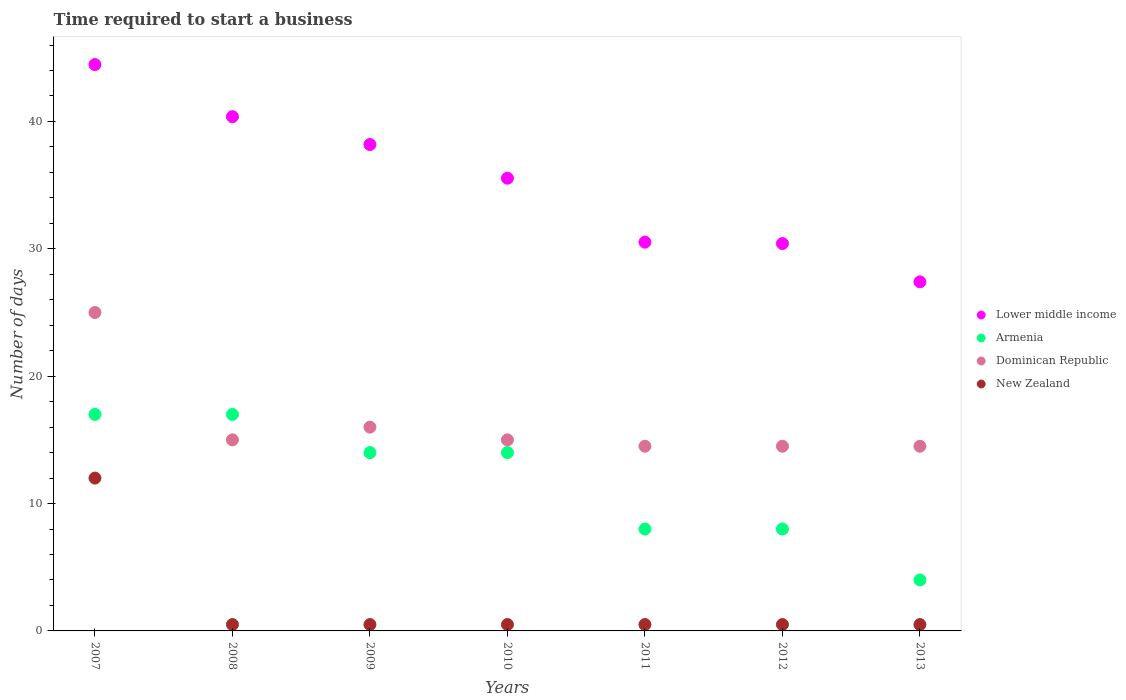What is the number of days required to start a business in New Zealand in 2011?
Provide a succinct answer. 0.5. Across all years, what is the maximum number of days required to start a business in Lower middle income?
Provide a short and direct response. 44.47. In which year was the number of days required to start a business in Lower middle income maximum?
Offer a terse response. 2007. What is the total number of days required to start a business in Armenia in the graph?
Offer a terse response. 82. What is the difference between the number of days required to start a business in Lower middle income in 2010 and that in 2013?
Offer a terse response. 8.14. What is the difference between the number of days required to start a business in Dominican Republic in 2009 and the number of days required to start a business in Lower middle income in 2007?
Your response must be concise. -28.47. What is the average number of days required to start a business in Armenia per year?
Your answer should be very brief. 11.71. In the year 2007, what is the difference between the number of days required to start a business in Armenia and number of days required to start a business in New Zealand?
Your response must be concise. 5. What is the ratio of the number of days required to start a business in Lower middle income in 2007 to that in 2013?
Your answer should be compact. 1.62. Is the number of days required to start a business in New Zealand in 2007 less than that in 2013?
Offer a terse response. No. Is the difference between the number of days required to start a business in Armenia in 2007 and 2012 greater than the difference between the number of days required to start a business in New Zealand in 2007 and 2012?
Make the answer very short. No. What is the difference between the highest and the second highest number of days required to start a business in Dominican Republic?
Ensure brevity in your answer.  9. What is the difference between the highest and the lowest number of days required to start a business in New Zealand?
Your response must be concise. 11.5. Is the sum of the number of days required to start a business in New Zealand in 2008 and 2009 greater than the maximum number of days required to start a business in Armenia across all years?
Keep it short and to the point. No. Is it the case that in every year, the sum of the number of days required to start a business in Armenia and number of days required to start a business in Lower middle income  is greater than the number of days required to start a business in Dominican Republic?
Offer a terse response. Yes. Does the number of days required to start a business in New Zealand monotonically increase over the years?
Ensure brevity in your answer.  No. Is the number of days required to start a business in Armenia strictly less than the number of days required to start a business in Lower middle income over the years?
Ensure brevity in your answer.  Yes. How many dotlines are there?
Your answer should be very brief. 4. How many years are there in the graph?
Provide a succinct answer. 7. What is the difference between two consecutive major ticks on the Y-axis?
Offer a very short reply. 10. Are the values on the major ticks of Y-axis written in scientific E-notation?
Your response must be concise. No. How many legend labels are there?
Your answer should be very brief. 4. What is the title of the graph?
Provide a succinct answer. Time required to start a business. Does "United Kingdom" appear as one of the legend labels in the graph?
Provide a short and direct response. No. What is the label or title of the Y-axis?
Your answer should be compact. Number of days. What is the Number of days of Lower middle income in 2007?
Your answer should be very brief. 44.47. What is the Number of days in Dominican Republic in 2007?
Your answer should be very brief. 25. What is the Number of days in Lower middle income in 2008?
Provide a succinct answer. 40.38. What is the Number of days of Armenia in 2008?
Your answer should be very brief. 17. What is the Number of days in Dominican Republic in 2008?
Provide a short and direct response. 15. What is the Number of days of Lower middle income in 2009?
Make the answer very short. 38.19. What is the Number of days in Armenia in 2009?
Offer a terse response. 14. What is the Number of days in Lower middle income in 2010?
Give a very brief answer. 35.54. What is the Number of days in New Zealand in 2010?
Provide a succinct answer. 0.5. What is the Number of days in Lower middle income in 2011?
Ensure brevity in your answer.  30.52. What is the Number of days in Armenia in 2011?
Your answer should be compact. 8. What is the Number of days in New Zealand in 2011?
Make the answer very short. 0.5. What is the Number of days in Lower middle income in 2012?
Your answer should be very brief. 30.41. What is the Number of days of Armenia in 2012?
Your response must be concise. 8. What is the Number of days in Dominican Republic in 2012?
Your answer should be compact. 14.5. What is the Number of days in Lower middle income in 2013?
Offer a terse response. 27.41. What is the Number of days of Armenia in 2013?
Provide a succinct answer. 4. Across all years, what is the maximum Number of days of Lower middle income?
Make the answer very short. 44.47. Across all years, what is the maximum Number of days of Armenia?
Provide a succinct answer. 17. Across all years, what is the maximum Number of days of New Zealand?
Keep it short and to the point. 12. Across all years, what is the minimum Number of days in Lower middle income?
Your response must be concise. 27.41. Across all years, what is the minimum Number of days of Dominican Republic?
Keep it short and to the point. 14.5. Across all years, what is the minimum Number of days in New Zealand?
Your answer should be compact. 0.5. What is the total Number of days of Lower middle income in the graph?
Your answer should be compact. 246.92. What is the total Number of days in Dominican Republic in the graph?
Keep it short and to the point. 114.5. What is the total Number of days of New Zealand in the graph?
Your response must be concise. 15. What is the difference between the Number of days of Lower middle income in 2007 and that in 2008?
Provide a short and direct response. 4.09. What is the difference between the Number of days in Dominican Republic in 2007 and that in 2008?
Your answer should be very brief. 10. What is the difference between the Number of days of New Zealand in 2007 and that in 2008?
Your answer should be compact. 11.5. What is the difference between the Number of days of Lower middle income in 2007 and that in 2009?
Offer a terse response. 6.28. What is the difference between the Number of days of Armenia in 2007 and that in 2009?
Keep it short and to the point. 3. What is the difference between the Number of days in Lower middle income in 2007 and that in 2010?
Give a very brief answer. 8.92. What is the difference between the Number of days of Armenia in 2007 and that in 2010?
Your response must be concise. 3. What is the difference between the Number of days of Dominican Republic in 2007 and that in 2010?
Keep it short and to the point. 10. What is the difference between the Number of days of New Zealand in 2007 and that in 2010?
Your answer should be very brief. 11.5. What is the difference between the Number of days in Lower middle income in 2007 and that in 2011?
Offer a terse response. 13.94. What is the difference between the Number of days of Armenia in 2007 and that in 2011?
Offer a very short reply. 9. What is the difference between the Number of days in New Zealand in 2007 and that in 2011?
Your answer should be compact. 11.5. What is the difference between the Number of days in Lower middle income in 2007 and that in 2012?
Give a very brief answer. 14.05. What is the difference between the Number of days in Dominican Republic in 2007 and that in 2012?
Your answer should be compact. 10.5. What is the difference between the Number of days in New Zealand in 2007 and that in 2012?
Make the answer very short. 11.5. What is the difference between the Number of days in Lower middle income in 2007 and that in 2013?
Offer a very short reply. 17.06. What is the difference between the Number of days of Armenia in 2007 and that in 2013?
Your response must be concise. 13. What is the difference between the Number of days in New Zealand in 2007 and that in 2013?
Ensure brevity in your answer.  11.5. What is the difference between the Number of days of Lower middle income in 2008 and that in 2009?
Your answer should be compact. 2.19. What is the difference between the Number of days of New Zealand in 2008 and that in 2009?
Offer a terse response. 0. What is the difference between the Number of days of Lower middle income in 2008 and that in 2010?
Your answer should be compact. 4.83. What is the difference between the Number of days of Armenia in 2008 and that in 2010?
Your answer should be very brief. 3. What is the difference between the Number of days of Lower middle income in 2008 and that in 2011?
Offer a very short reply. 9.85. What is the difference between the Number of days of New Zealand in 2008 and that in 2011?
Provide a succinct answer. 0. What is the difference between the Number of days of Lower middle income in 2008 and that in 2012?
Your response must be concise. 9.96. What is the difference between the Number of days of Lower middle income in 2008 and that in 2013?
Your answer should be very brief. 12.97. What is the difference between the Number of days in Armenia in 2008 and that in 2013?
Offer a terse response. 13. What is the difference between the Number of days in Dominican Republic in 2008 and that in 2013?
Make the answer very short. 0.5. What is the difference between the Number of days in Lower middle income in 2009 and that in 2010?
Give a very brief answer. 2.64. What is the difference between the Number of days in Dominican Republic in 2009 and that in 2010?
Give a very brief answer. 1. What is the difference between the Number of days in Lower middle income in 2009 and that in 2011?
Provide a short and direct response. 7.67. What is the difference between the Number of days in Lower middle income in 2009 and that in 2012?
Your response must be concise. 7.78. What is the difference between the Number of days in Dominican Republic in 2009 and that in 2012?
Give a very brief answer. 1.5. What is the difference between the Number of days in Lower middle income in 2009 and that in 2013?
Give a very brief answer. 10.78. What is the difference between the Number of days of Armenia in 2009 and that in 2013?
Offer a very short reply. 10. What is the difference between the Number of days of Lower middle income in 2010 and that in 2011?
Give a very brief answer. 5.02. What is the difference between the Number of days in Armenia in 2010 and that in 2011?
Your response must be concise. 6. What is the difference between the Number of days in New Zealand in 2010 and that in 2011?
Offer a terse response. 0. What is the difference between the Number of days of Lower middle income in 2010 and that in 2012?
Keep it short and to the point. 5.13. What is the difference between the Number of days in New Zealand in 2010 and that in 2012?
Your response must be concise. 0. What is the difference between the Number of days in Lower middle income in 2010 and that in 2013?
Your answer should be compact. 8.14. What is the difference between the Number of days of Armenia in 2010 and that in 2013?
Your response must be concise. 10. What is the difference between the Number of days of Dominican Republic in 2010 and that in 2013?
Give a very brief answer. 0.5. What is the difference between the Number of days of New Zealand in 2010 and that in 2013?
Give a very brief answer. 0. What is the difference between the Number of days of Lower middle income in 2011 and that in 2012?
Provide a short and direct response. 0.11. What is the difference between the Number of days in Lower middle income in 2011 and that in 2013?
Your answer should be very brief. 3.11. What is the difference between the Number of days in Dominican Republic in 2011 and that in 2013?
Your answer should be very brief. 0. What is the difference between the Number of days of Lower middle income in 2012 and that in 2013?
Keep it short and to the point. 3.01. What is the difference between the Number of days in Lower middle income in 2007 and the Number of days in Armenia in 2008?
Offer a terse response. 27.47. What is the difference between the Number of days of Lower middle income in 2007 and the Number of days of Dominican Republic in 2008?
Provide a succinct answer. 29.47. What is the difference between the Number of days in Lower middle income in 2007 and the Number of days in New Zealand in 2008?
Offer a terse response. 43.97. What is the difference between the Number of days of Lower middle income in 2007 and the Number of days of Armenia in 2009?
Provide a succinct answer. 30.47. What is the difference between the Number of days in Lower middle income in 2007 and the Number of days in Dominican Republic in 2009?
Offer a very short reply. 28.47. What is the difference between the Number of days of Lower middle income in 2007 and the Number of days of New Zealand in 2009?
Offer a very short reply. 43.97. What is the difference between the Number of days in Armenia in 2007 and the Number of days in New Zealand in 2009?
Ensure brevity in your answer.  16.5. What is the difference between the Number of days of Lower middle income in 2007 and the Number of days of Armenia in 2010?
Your answer should be compact. 30.47. What is the difference between the Number of days in Lower middle income in 2007 and the Number of days in Dominican Republic in 2010?
Your response must be concise. 29.47. What is the difference between the Number of days in Lower middle income in 2007 and the Number of days in New Zealand in 2010?
Keep it short and to the point. 43.97. What is the difference between the Number of days in Armenia in 2007 and the Number of days in Dominican Republic in 2010?
Offer a very short reply. 2. What is the difference between the Number of days of Dominican Republic in 2007 and the Number of days of New Zealand in 2010?
Your answer should be very brief. 24.5. What is the difference between the Number of days of Lower middle income in 2007 and the Number of days of Armenia in 2011?
Provide a short and direct response. 36.47. What is the difference between the Number of days of Lower middle income in 2007 and the Number of days of Dominican Republic in 2011?
Your answer should be very brief. 29.97. What is the difference between the Number of days in Lower middle income in 2007 and the Number of days in New Zealand in 2011?
Ensure brevity in your answer.  43.97. What is the difference between the Number of days of Lower middle income in 2007 and the Number of days of Armenia in 2012?
Keep it short and to the point. 36.47. What is the difference between the Number of days in Lower middle income in 2007 and the Number of days in Dominican Republic in 2012?
Your answer should be very brief. 29.97. What is the difference between the Number of days in Lower middle income in 2007 and the Number of days in New Zealand in 2012?
Give a very brief answer. 43.97. What is the difference between the Number of days of Lower middle income in 2007 and the Number of days of Armenia in 2013?
Your answer should be very brief. 40.47. What is the difference between the Number of days of Lower middle income in 2007 and the Number of days of Dominican Republic in 2013?
Your answer should be very brief. 29.97. What is the difference between the Number of days in Lower middle income in 2007 and the Number of days in New Zealand in 2013?
Provide a short and direct response. 43.97. What is the difference between the Number of days of Armenia in 2007 and the Number of days of Dominican Republic in 2013?
Give a very brief answer. 2.5. What is the difference between the Number of days of Armenia in 2007 and the Number of days of New Zealand in 2013?
Your answer should be very brief. 16.5. What is the difference between the Number of days in Dominican Republic in 2007 and the Number of days in New Zealand in 2013?
Provide a succinct answer. 24.5. What is the difference between the Number of days of Lower middle income in 2008 and the Number of days of Armenia in 2009?
Your answer should be compact. 26.38. What is the difference between the Number of days in Lower middle income in 2008 and the Number of days in Dominican Republic in 2009?
Offer a terse response. 24.38. What is the difference between the Number of days of Lower middle income in 2008 and the Number of days of New Zealand in 2009?
Your answer should be very brief. 39.88. What is the difference between the Number of days of Armenia in 2008 and the Number of days of Dominican Republic in 2009?
Make the answer very short. 1. What is the difference between the Number of days in Dominican Republic in 2008 and the Number of days in New Zealand in 2009?
Your answer should be very brief. 14.5. What is the difference between the Number of days in Lower middle income in 2008 and the Number of days in Armenia in 2010?
Your answer should be compact. 26.38. What is the difference between the Number of days in Lower middle income in 2008 and the Number of days in Dominican Republic in 2010?
Your answer should be compact. 25.38. What is the difference between the Number of days of Lower middle income in 2008 and the Number of days of New Zealand in 2010?
Provide a short and direct response. 39.88. What is the difference between the Number of days of Armenia in 2008 and the Number of days of Dominican Republic in 2010?
Make the answer very short. 2. What is the difference between the Number of days of Dominican Republic in 2008 and the Number of days of New Zealand in 2010?
Keep it short and to the point. 14.5. What is the difference between the Number of days of Lower middle income in 2008 and the Number of days of Armenia in 2011?
Provide a short and direct response. 32.38. What is the difference between the Number of days in Lower middle income in 2008 and the Number of days in Dominican Republic in 2011?
Provide a short and direct response. 25.88. What is the difference between the Number of days in Lower middle income in 2008 and the Number of days in New Zealand in 2011?
Your answer should be very brief. 39.88. What is the difference between the Number of days of Armenia in 2008 and the Number of days of Dominican Republic in 2011?
Offer a very short reply. 2.5. What is the difference between the Number of days of Armenia in 2008 and the Number of days of New Zealand in 2011?
Offer a terse response. 16.5. What is the difference between the Number of days of Lower middle income in 2008 and the Number of days of Armenia in 2012?
Offer a very short reply. 32.38. What is the difference between the Number of days of Lower middle income in 2008 and the Number of days of Dominican Republic in 2012?
Make the answer very short. 25.88. What is the difference between the Number of days in Lower middle income in 2008 and the Number of days in New Zealand in 2012?
Offer a very short reply. 39.88. What is the difference between the Number of days of Armenia in 2008 and the Number of days of New Zealand in 2012?
Offer a terse response. 16.5. What is the difference between the Number of days in Lower middle income in 2008 and the Number of days in Armenia in 2013?
Your answer should be compact. 36.38. What is the difference between the Number of days of Lower middle income in 2008 and the Number of days of Dominican Republic in 2013?
Your answer should be compact. 25.88. What is the difference between the Number of days in Lower middle income in 2008 and the Number of days in New Zealand in 2013?
Provide a short and direct response. 39.88. What is the difference between the Number of days in Lower middle income in 2009 and the Number of days in Armenia in 2010?
Provide a short and direct response. 24.19. What is the difference between the Number of days in Lower middle income in 2009 and the Number of days in Dominican Republic in 2010?
Keep it short and to the point. 23.19. What is the difference between the Number of days in Lower middle income in 2009 and the Number of days in New Zealand in 2010?
Ensure brevity in your answer.  37.69. What is the difference between the Number of days of Armenia in 2009 and the Number of days of Dominican Republic in 2010?
Make the answer very short. -1. What is the difference between the Number of days of Lower middle income in 2009 and the Number of days of Armenia in 2011?
Make the answer very short. 30.19. What is the difference between the Number of days of Lower middle income in 2009 and the Number of days of Dominican Republic in 2011?
Provide a short and direct response. 23.69. What is the difference between the Number of days in Lower middle income in 2009 and the Number of days in New Zealand in 2011?
Offer a very short reply. 37.69. What is the difference between the Number of days in Lower middle income in 2009 and the Number of days in Armenia in 2012?
Ensure brevity in your answer.  30.19. What is the difference between the Number of days of Lower middle income in 2009 and the Number of days of Dominican Republic in 2012?
Offer a very short reply. 23.69. What is the difference between the Number of days in Lower middle income in 2009 and the Number of days in New Zealand in 2012?
Ensure brevity in your answer.  37.69. What is the difference between the Number of days in Armenia in 2009 and the Number of days in New Zealand in 2012?
Provide a short and direct response. 13.5. What is the difference between the Number of days of Lower middle income in 2009 and the Number of days of Armenia in 2013?
Ensure brevity in your answer.  34.19. What is the difference between the Number of days of Lower middle income in 2009 and the Number of days of Dominican Republic in 2013?
Your answer should be very brief. 23.69. What is the difference between the Number of days in Lower middle income in 2009 and the Number of days in New Zealand in 2013?
Your answer should be very brief. 37.69. What is the difference between the Number of days of Armenia in 2009 and the Number of days of New Zealand in 2013?
Your answer should be compact. 13.5. What is the difference between the Number of days of Lower middle income in 2010 and the Number of days of Armenia in 2011?
Keep it short and to the point. 27.54. What is the difference between the Number of days in Lower middle income in 2010 and the Number of days in Dominican Republic in 2011?
Keep it short and to the point. 21.04. What is the difference between the Number of days of Lower middle income in 2010 and the Number of days of New Zealand in 2011?
Keep it short and to the point. 35.04. What is the difference between the Number of days in Armenia in 2010 and the Number of days in Dominican Republic in 2011?
Give a very brief answer. -0.5. What is the difference between the Number of days of Lower middle income in 2010 and the Number of days of Armenia in 2012?
Provide a succinct answer. 27.54. What is the difference between the Number of days of Lower middle income in 2010 and the Number of days of Dominican Republic in 2012?
Your answer should be very brief. 21.04. What is the difference between the Number of days of Lower middle income in 2010 and the Number of days of New Zealand in 2012?
Provide a short and direct response. 35.04. What is the difference between the Number of days in Armenia in 2010 and the Number of days in New Zealand in 2012?
Your answer should be very brief. 13.5. What is the difference between the Number of days of Lower middle income in 2010 and the Number of days of Armenia in 2013?
Your answer should be very brief. 31.54. What is the difference between the Number of days in Lower middle income in 2010 and the Number of days in Dominican Republic in 2013?
Offer a terse response. 21.04. What is the difference between the Number of days of Lower middle income in 2010 and the Number of days of New Zealand in 2013?
Ensure brevity in your answer.  35.04. What is the difference between the Number of days in Armenia in 2010 and the Number of days in New Zealand in 2013?
Keep it short and to the point. 13.5. What is the difference between the Number of days of Dominican Republic in 2010 and the Number of days of New Zealand in 2013?
Offer a terse response. 14.5. What is the difference between the Number of days of Lower middle income in 2011 and the Number of days of Armenia in 2012?
Offer a very short reply. 22.52. What is the difference between the Number of days in Lower middle income in 2011 and the Number of days in Dominican Republic in 2012?
Offer a terse response. 16.02. What is the difference between the Number of days in Lower middle income in 2011 and the Number of days in New Zealand in 2012?
Provide a succinct answer. 30.02. What is the difference between the Number of days in Armenia in 2011 and the Number of days in New Zealand in 2012?
Provide a short and direct response. 7.5. What is the difference between the Number of days in Lower middle income in 2011 and the Number of days in Armenia in 2013?
Your answer should be compact. 26.52. What is the difference between the Number of days of Lower middle income in 2011 and the Number of days of Dominican Republic in 2013?
Offer a terse response. 16.02. What is the difference between the Number of days of Lower middle income in 2011 and the Number of days of New Zealand in 2013?
Make the answer very short. 30.02. What is the difference between the Number of days in Armenia in 2011 and the Number of days in Dominican Republic in 2013?
Your answer should be compact. -6.5. What is the difference between the Number of days of Armenia in 2011 and the Number of days of New Zealand in 2013?
Keep it short and to the point. 7.5. What is the difference between the Number of days in Dominican Republic in 2011 and the Number of days in New Zealand in 2013?
Offer a very short reply. 14. What is the difference between the Number of days of Lower middle income in 2012 and the Number of days of Armenia in 2013?
Provide a short and direct response. 26.41. What is the difference between the Number of days in Lower middle income in 2012 and the Number of days in Dominican Republic in 2013?
Your answer should be very brief. 15.91. What is the difference between the Number of days in Lower middle income in 2012 and the Number of days in New Zealand in 2013?
Provide a short and direct response. 29.91. What is the difference between the Number of days in Armenia in 2012 and the Number of days in New Zealand in 2013?
Provide a short and direct response. 7.5. What is the difference between the Number of days in Dominican Republic in 2012 and the Number of days in New Zealand in 2013?
Make the answer very short. 14. What is the average Number of days in Lower middle income per year?
Provide a short and direct response. 35.27. What is the average Number of days of Armenia per year?
Make the answer very short. 11.71. What is the average Number of days in Dominican Republic per year?
Your answer should be compact. 16.36. What is the average Number of days in New Zealand per year?
Make the answer very short. 2.14. In the year 2007, what is the difference between the Number of days in Lower middle income and Number of days in Armenia?
Ensure brevity in your answer.  27.47. In the year 2007, what is the difference between the Number of days in Lower middle income and Number of days in Dominican Republic?
Make the answer very short. 19.47. In the year 2007, what is the difference between the Number of days in Lower middle income and Number of days in New Zealand?
Give a very brief answer. 32.47. In the year 2007, what is the difference between the Number of days of Armenia and Number of days of Dominican Republic?
Provide a succinct answer. -8. In the year 2007, what is the difference between the Number of days of Armenia and Number of days of New Zealand?
Offer a very short reply. 5. In the year 2007, what is the difference between the Number of days in Dominican Republic and Number of days in New Zealand?
Your answer should be very brief. 13. In the year 2008, what is the difference between the Number of days of Lower middle income and Number of days of Armenia?
Make the answer very short. 23.38. In the year 2008, what is the difference between the Number of days in Lower middle income and Number of days in Dominican Republic?
Your response must be concise. 25.38. In the year 2008, what is the difference between the Number of days in Lower middle income and Number of days in New Zealand?
Your response must be concise. 39.88. In the year 2008, what is the difference between the Number of days in Armenia and Number of days in New Zealand?
Make the answer very short. 16.5. In the year 2008, what is the difference between the Number of days of Dominican Republic and Number of days of New Zealand?
Give a very brief answer. 14.5. In the year 2009, what is the difference between the Number of days of Lower middle income and Number of days of Armenia?
Provide a short and direct response. 24.19. In the year 2009, what is the difference between the Number of days of Lower middle income and Number of days of Dominican Republic?
Your response must be concise. 22.19. In the year 2009, what is the difference between the Number of days in Lower middle income and Number of days in New Zealand?
Make the answer very short. 37.69. In the year 2009, what is the difference between the Number of days of Armenia and Number of days of New Zealand?
Offer a terse response. 13.5. In the year 2010, what is the difference between the Number of days of Lower middle income and Number of days of Armenia?
Your answer should be very brief. 21.54. In the year 2010, what is the difference between the Number of days in Lower middle income and Number of days in Dominican Republic?
Ensure brevity in your answer.  20.54. In the year 2010, what is the difference between the Number of days in Lower middle income and Number of days in New Zealand?
Ensure brevity in your answer.  35.04. In the year 2010, what is the difference between the Number of days in Armenia and Number of days in Dominican Republic?
Ensure brevity in your answer.  -1. In the year 2011, what is the difference between the Number of days of Lower middle income and Number of days of Armenia?
Give a very brief answer. 22.52. In the year 2011, what is the difference between the Number of days in Lower middle income and Number of days in Dominican Republic?
Your answer should be very brief. 16.02. In the year 2011, what is the difference between the Number of days in Lower middle income and Number of days in New Zealand?
Your answer should be very brief. 30.02. In the year 2011, what is the difference between the Number of days of Armenia and Number of days of Dominican Republic?
Ensure brevity in your answer.  -6.5. In the year 2012, what is the difference between the Number of days in Lower middle income and Number of days in Armenia?
Provide a short and direct response. 22.41. In the year 2012, what is the difference between the Number of days of Lower middle income and Number of days of Dominican Republic?
Provide a succinct answer. 15.91. In the year 2012, what is the difference between the Number of days of Lower middle income and Number of days of New Zealand?
Offer a very short reply. 29.91. In the year 2012, what is the difference between the Number of days of Armenia and Number of days of Dominican Republic?
Give a very brief answer. -6.5. In the year 2012, what is the difference between the Number of days of Armenia and Number of days of New Zealand?
Make the answer very short. 7.5. In the year 2012, what is the difference between the Number of days in Dominican Republic and Number of days in New Zealand?
Ensure brevity in your answer.  14. In the year 2013, what is the difference between the Number of days in Lower middle income and Number of days in Armenia?
Provide a short and direct response. 23.41. In the year 2013, what is the difference between the Number of days in Lower middle income and Number of days in Dominican Republic?
Provide a succinct answer. 12.91. In the year 2013, what is the difference between the Number of days in Lower middle income and Number of days in New Zealand?
Keep it short and to the point. 26.91. In the year 2013, what is the difference between the Number of days in Armenia and Number of days in Dominican Republic?
Your response must be concise. -10.5. In the year 2013, what is the difference between the Number of days of Armenia and Number of days of New Zealand?
Offer a terse response. 3.5. What is the ratio of the Number of days of Lower middle income in 2007 to that in 2008?
Keep it short and to the point. 1.1. What is the ratio of the Number of days of Lower middle income in 2007 to that in 2009?
Offer a terse response. 1.16. What is the ratio of the Number of days of Armenia in 2007 to that in 2009?
Offer a very short reply. 1.21. What is the ratio of the Number of days of Dominican Republic in 2007 to that in 2009?
Your response must be concise. 1.56. What is the ratio of the Number of days of New Zealand in 2007 to that in 2009?
Keep it short and to the point. 24. What is the ratio of the Number of days in Lower middle income in 2007 to that in 2010?
Your response must be concise. 1.25. What is the ratio of the Number of days of Armenia in 2007 to that in 2010?
Your answer should be very brief. 1.21. What is the ratio of the Number of days of Dominican Republic in 2007 to that in 2010?
Offer a very short reply. 1.67. What is the ratio of the Number of days in New Zealand in 2007 to that in 2010?
Make the answer very short. 24. What is the ratio of the Number of days in Lower middle income in 2007 to that in 2011?
Ensure brevity in your answer.  1.46. What is the ratio of the Number of days in Armenia in 2007 to that in 2011?
Your response must be concise. 2.12. What is the ratio of the Number of days in Dominican Republic in 2007 to that in 2011?
Provide a short and direct response. 1.72. What is the ratio of the Number of days of Lower middle income in 2007 to that in 2012?
Your answer should be compact. 1.46. What is the ratio of the Number of days of Armenia in 2007 to that in 2012?
Provide a short and direct response. 2.12. What is the ratio of the Number of days of Dominican Republic in 2007 to that in 2012?
Make the answer very short. 1.72. What is the ratio of the Number of days in New Zealand in 2007 to that in 2012?
Offer a terse response. 24. What is the ratio of the Number of days of Lower middle income in 2007 to that in 2013?
Make the answer very short. 1.62. What is the ratio of the Number of days of Armenia in 2007 to that in 2013?
Provide a short and direct response. 4.25. What is the ratio of the Number of days of Dominican Republic in 2007 to that in 2013?
Your response must be concise. 1.72. What is the ratio of the Number of days of New Zealand in 2007 to that in 2013?
Provide a succinct answer. 24. What is the ratio of the Number of days in Lower middle income in 2008 to that in 2009?
Your response must be concise. 1.06. What is the ratio of the Number of days in Armenia in 2008 to that in 2009?
Offer a very short reply. 1.21. What is the ratio of the Number of days in Dominican Republic in 2008 to that in 2009?
Offer a terse response. 0.94. What is the ratio of the Number of days of Lower middle income in 2008 to that in 2010?
Offer a terse response. 1.14. What is the ratio of the Number of days in Armenia in 2008 to that in 2010?
Ensure brevity in your answer.  1.21. What is the ratio of the Number of days in Lower middle income in 2008 to that in 2011?
Your response must be concise. 1.32. What is the ratio of the Number of days in Armenia in 2008 to that in 2011?
Your answer should be compact. 2.12. What is the ratio of the Number of days in Dominican Republic in 2008 to that in 2011?
Your response must be concise. 1.03. What is the ratio of the Number of days in New Zealand in 2008 to that in 2011?
Your response must be concise. 1. What is the ratio of the Number of days of Lower middle income in 2008 to that in 2012?
Provide a short and direct response. 1.33. What is the ratio of the Number of days of Armenia in 2008 to that in 2012?
Offer a very short reply. 2.12. What is the ratio of the Number of days of Dominican Republic in 2008 to that in 2012?
Ensure brevity in your answer.  1.03. What is the ratio of the Number of days of Lower middle income in 2008 to that in 2013?
Provide a succinct answer. 1.47. What is the ratio of the Number of days of Armenia in 2008 to that in 2013?
Your answer should be compact. 4.25. What is the ratio of the Number of days in Dominican Republic in 2008 to that in 2013?
Offer a very short reply. 1.03. What is the ratio of the Number of days of New Zealand in 2008 to that in 2013?
Your response must be concise. 1. What is the ratio of the Number of days in Lower middle income in 2009 to that in 2010?
Provide a short and direct response. 1.07. What is the ratio of the Number of days of Armenia in 2009 to that in 2010?
Your response must be concise. 1. What is the ratio of the Number of days in Dominican Republic in 2009 to that in 2010?
Make the answer very short. 1.07. What is the ratio of the Number of days of Lower middle income in 2009 to that in 2011?
Give a very brief answer. 1.25. What is the ratio of the Number of days of Dominican Republic in 2009 to that in 2011?
Your response must be concise. 1.1. What is the ratio of the Number of days of Lower middle income in 2009 to that in 2012?
Your answer should be compact. 1.26. What is the ratio of the Number of days in Dominican Republic in 2009 to that in 2012?
Your answer should be very brief. 1.1. What is the ratio of the Number of days in Lower middle income in 2009 to that in 2013?
Provide a short and direct response. 1.39. What is the ratio of the Number of days in Dominican Republic in 2009 to that in 2013?
Provide a short and direct response. 1.1. What is the ratio of the Number of days in Lower middle income in 2010 to that in 2011?
Provide a succinct answer. 1.16. What is the ratio of the Number of days of Armenia in 2010 to that in 2011?
Provide a succinct answer. 1.75. What is the ratio of the Number of days in Dominican Republic in 2010 to that in 2011?
Your response must be concise. 1.03. What is the ratio of the Number of days of Lower middle income in 2010 to that in 2012?
Give a very brief answer. 1.17. What is the ratio of the Number of days of Dominican Republic in 2010 to that in 2012?
Your response must be concise. 1.03. What is the ratio of the Number of days in New Zealand in 2010 to that in 2012?
Offer a terse response. 1. What is the ratio of the Number of days in Lower middle income in 2010 to that in 2013?
Your answer should be compact. 1.3. What is the ratio of the Number of days in Armenia in 2010 to that in 2013?
Give a very brief answer. 3.5. What is the ratio of the Number of days of Dominican Republic in 2010 to that in 2013?
Keep it short and to the point. 1.03. What is the ratio of the Number of days of Lower middle income in 2011 to that in 2012?
Offer a terse response. 1. What is the ratio of the Number of days of Armenia in 2011 to that in 2012?
Ensure brevity in your answer.  1. What is the ratio of the Number of days of New Zealand in 2011 to that in 2012?
Provide a succinct answer. 1. What is the ratio of the Number of days in Lower middle income in 2011 to that in 2013?
Provide a succinct answer. 1.11. What is the ratio of the Number of days in Armenia in 2011 to that in 2013?
Provide a short and direct response. 2. What is the ratio of the Number of days of New Zealand in 2011 to that in 2013?
Your response must be concise. 1. What is the ratio of the Number of days of Lower middle income in 2012 to that in 2013?
Keep it short and to the point. 1.11. What is the ratio of the Number of days in Dominican Republic in 2012 to that in 2013?
Your answer should be compact. 1. What is the difference between the highest and the second highest Number of days in Lower middle income?
Give a very brief answer. 4.09. What is the difference between the highest and the second highest Number of days of Armenia?
Offer a very short reply. 0. What is the difference between the highest and the second highest Number of days of Dominican Republic?
Provide a succinct answer. 9. What is the difference between the highest and the second highest Number of days of New Zealand?
Make the answer very short. 11.5. What is the difference between the highest and the lowest Number of days in Lower middle income?
Keep it short and to the point. 17.06. What is the difference between the highest and the lowest Number of days in Dominican Republic?
Ensure brevity in your answer.  10.5. What is the difference between the highest and the lowest Number of days of New Zealand?
Offer a very short reply. 11.5. 